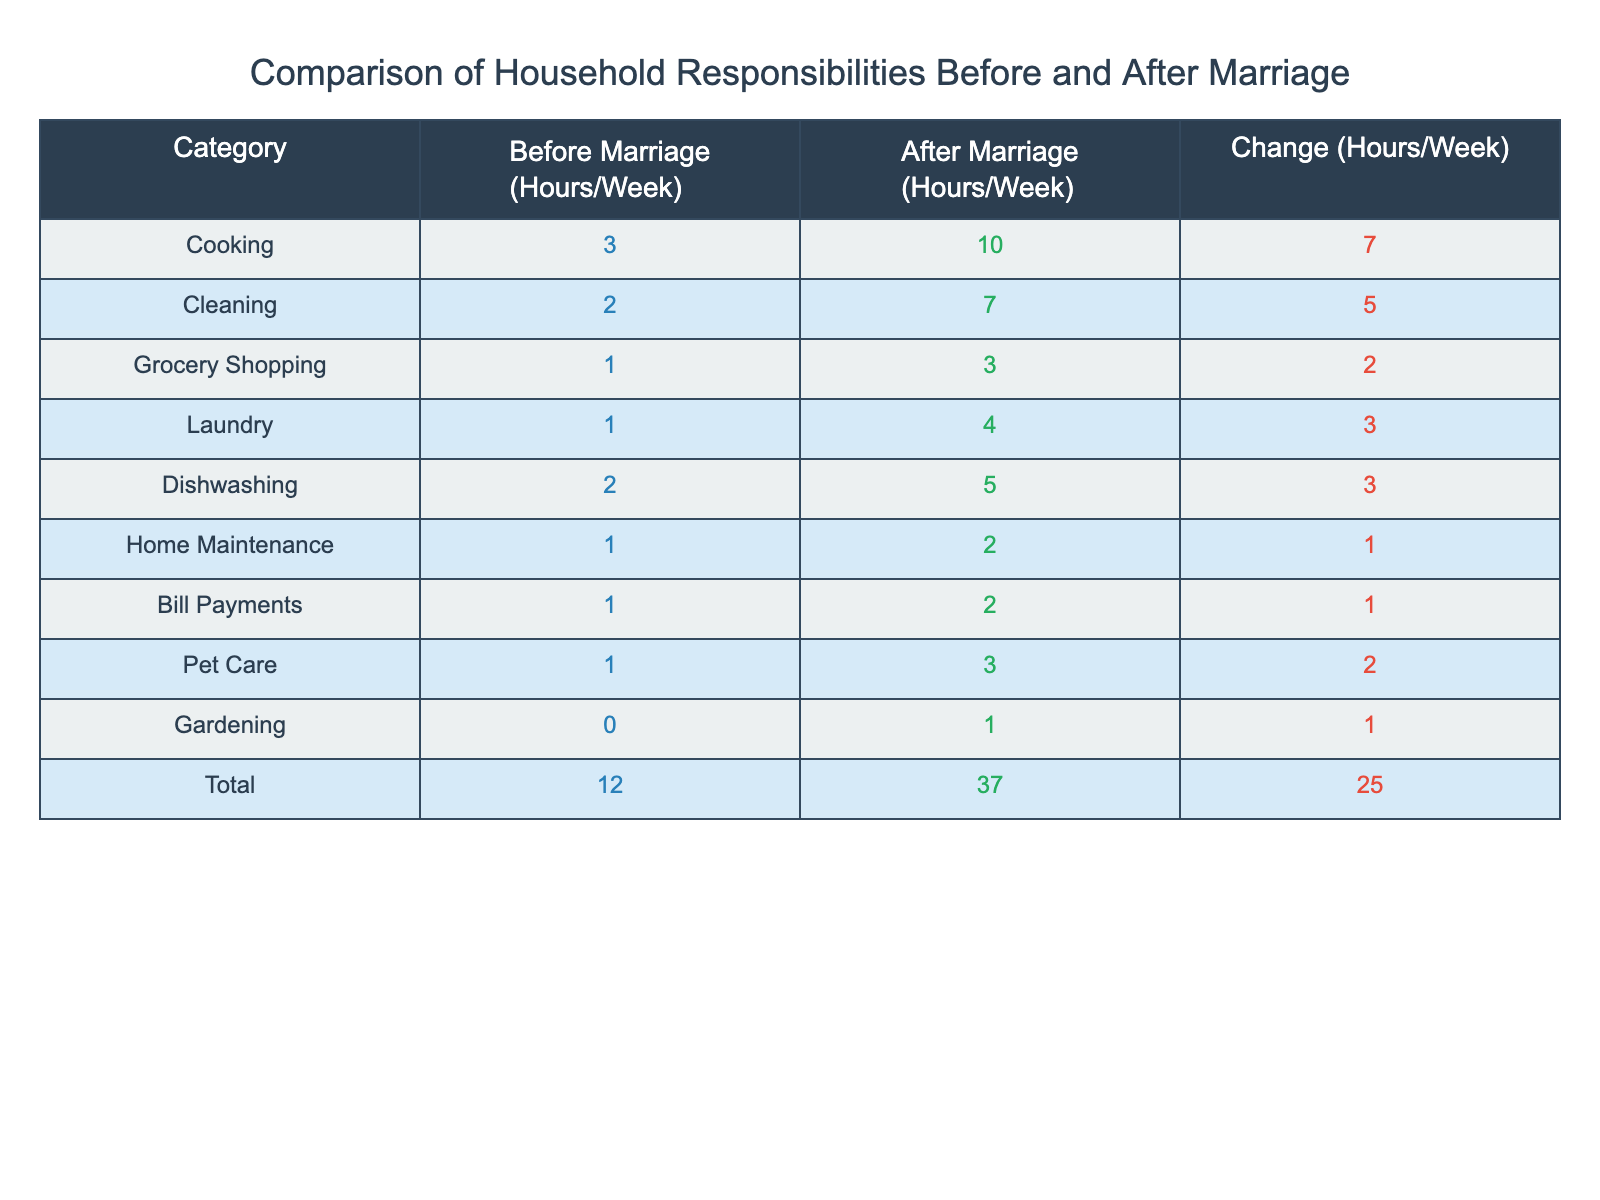What is the total number of hours spent on household responsibilities before marriage? By looking at the total row in the table, the hours spent before marriage are listed as 12 hours per week.
Answer: 12 How many hours were spent on cooking after marriage? The table indicates that 10 hours per week were spent on cooking after marriage.
Answer: 10 Is the amount of time spent on laundry greater after marriage compared to before marriage? Before marriage, 1 hour was spent on laundry, and after marriage, it increased to 4 hours. Therefore, it is greater after marriage.
Answer: Yes What is the change in hours spent on grocery shopping from before to after marriage? The table shows that grocery shopping took 1 hour before marriage and 3 hours after marriage, resulting in a change of +2 hours.
Answer: +2 What is the average time spent on household tasks before marriage? To find the average, add up all the hours before marriage (3 + 2 + 1 + 1 + 2 + 1 + 1 + 1 + 0 = 12) and divide by the number of categories (9). So the average is 12/9 = 1.33 hours per week.
Answer: 1.33 How much more time is spent on cleaning after marriage compared to before marriage? Cleaning took 2 hours before marriage and 7 hours after marriage, so the increase is 7 - 2 = 5 hours.
Answer: 5 Is the total time spent on household responsibilities after marriage less than 40 hours per week? The total after marriage is 37 hours, which is less than 40 hours.
Answer: No What percentage increase in time spent on dishwashing does the table indicate? The increase in dishwashing time is from 2 hours to 5 hours, which is an increase of 3 hours. The percentage increase is (3 / 2) * 100 = 150%.
Answer: 150% Considering all categories, did cooking see the highest change in hours after marriage? The greatest change when comparing categories is cooking, which increased by 7 hours, more than any other category.
Answer: Yes 